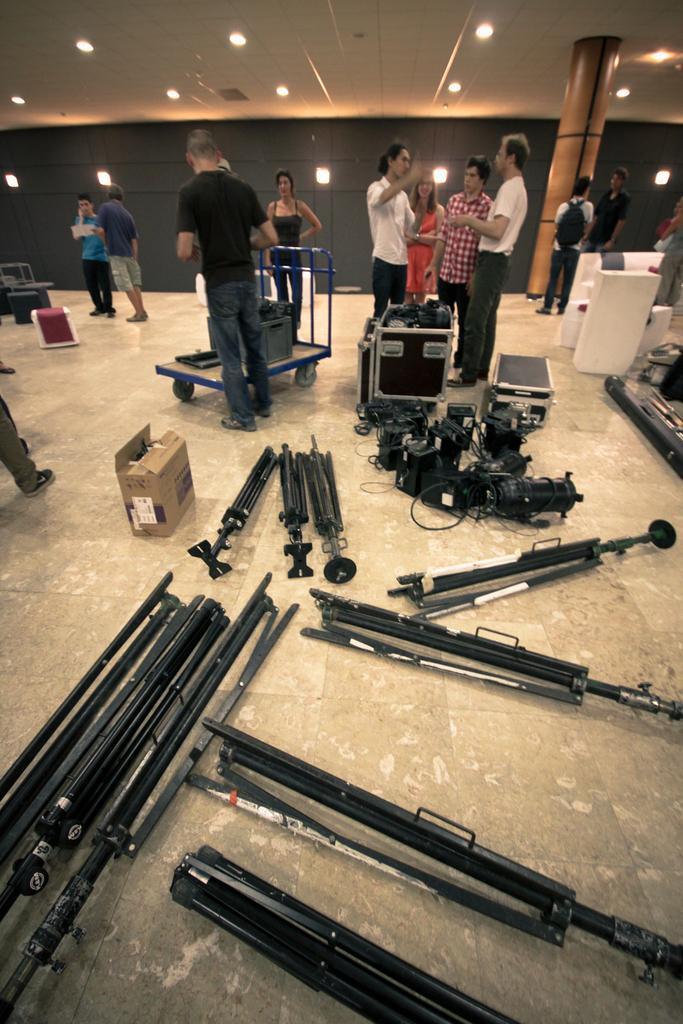Could you give a brief overview of what you see in this image? In this image we can see people are standing on the floor. On the floor, we can see so many different metal objects, a cart and cartoon box. In the background, we can see a wall with lights. At the top of the image, we can see a roof with lights. There is a pillar in the right top of the image. 